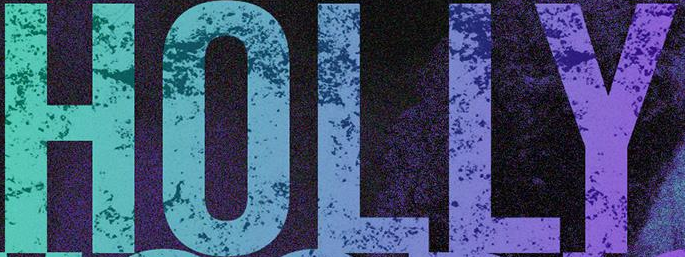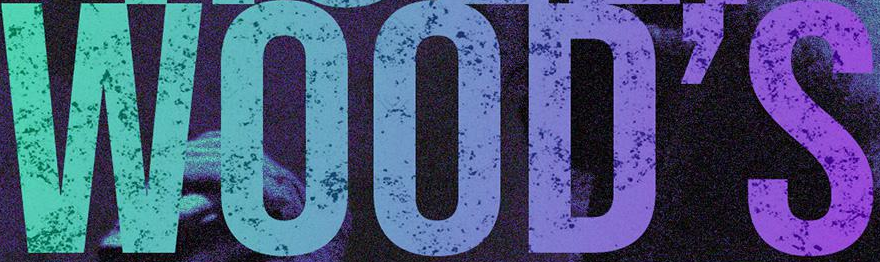Read the text content from these images in order, separated by a semicolon. HOLLY; WOOD'S 